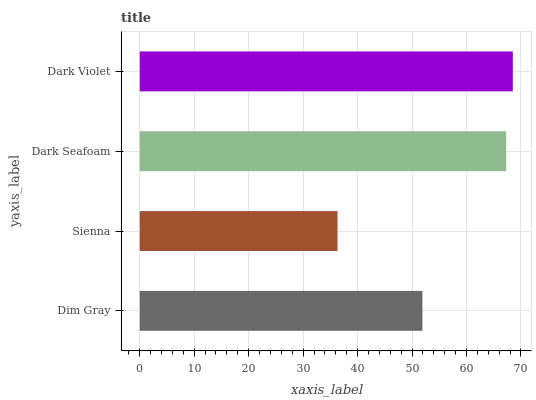Is Sienna the minimum?
Answer yes or no. Yes. Is Dark Violet the maximum?
Answer yes or no. Yes. Is Dark Seafoam the minimum?
Answer yes or no. No. Is Dark Seafoam the maximum?
Answer yes or no. No. Is Dark Seafoam greater than Sienna?
Answer yes or no. Yes. Is Sienna less than Dark Seafoam?
Answer yes or no. Yes. Is Sienna greater than Dark Seafoam?
Answer yes or no. No. Is Dark Seafoam less than Sienna?
Answer yes or no. No. Is Dark Seafoam the high median?
Answer yes or no. Yes. Is Dim Gray the low median?
Answer yes or no. Yes. Is Dim Gray the high median?
Answer yes or no. No. Is Sienna the low median?
Answer yes or no. No. 